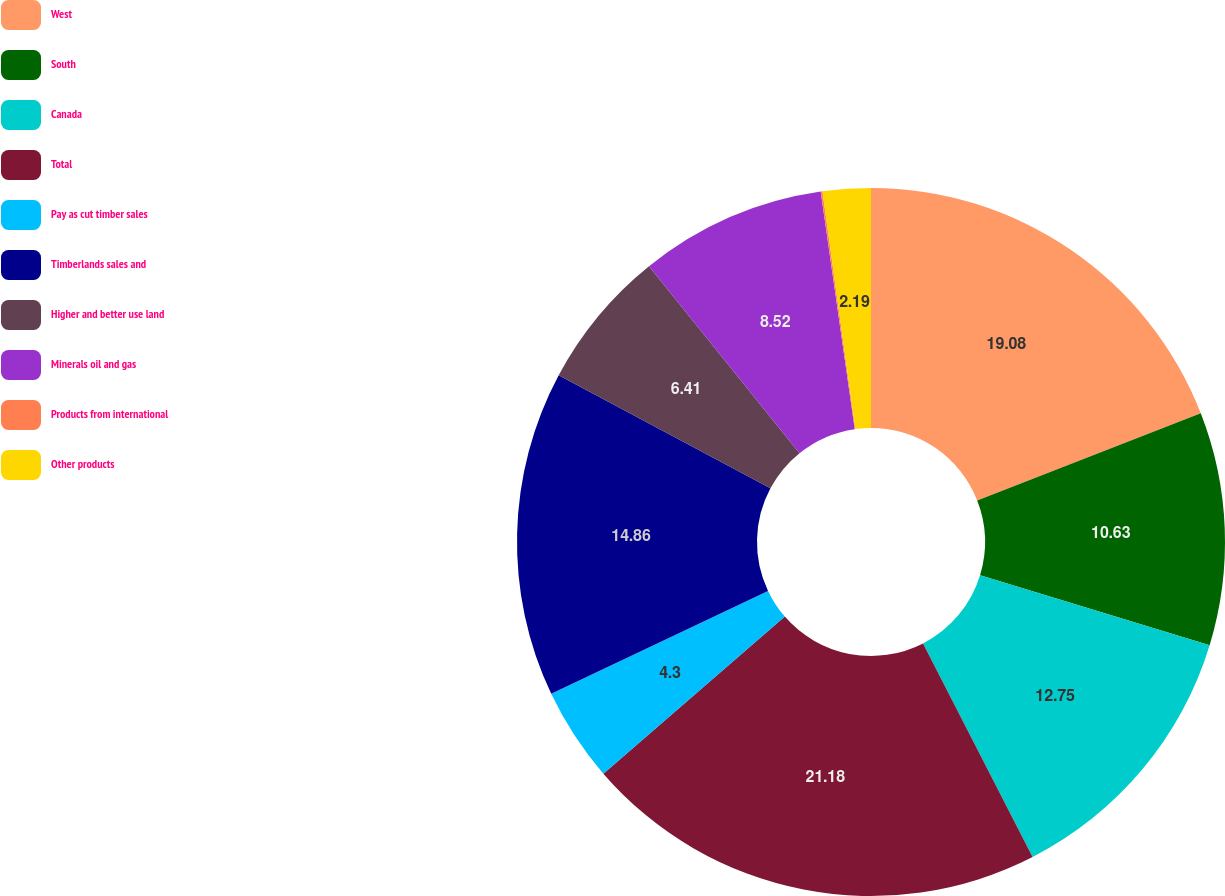Convert chart. <chart><loc_0><loc_0><loc_500><loc_500><pie_chart><fcel>West<fcel>South<fcel>Canada<fcel>Total<fcel>Pay as cut timber sales<fcel>Timberlands sales and<fcel>Higher and better use land<fcel>Minerals oil and gas<fcel>Products from international<fcel>Other products<nl><fcel>19.08%<fcel>10.63%<fcel>12.75%<fcel>21.19%<fcel>4.3%<fcel>14.86%<fcel>6.41%<fcel>8.52%<fcel>0.08%<fcel>2.19%<nl></chart> 